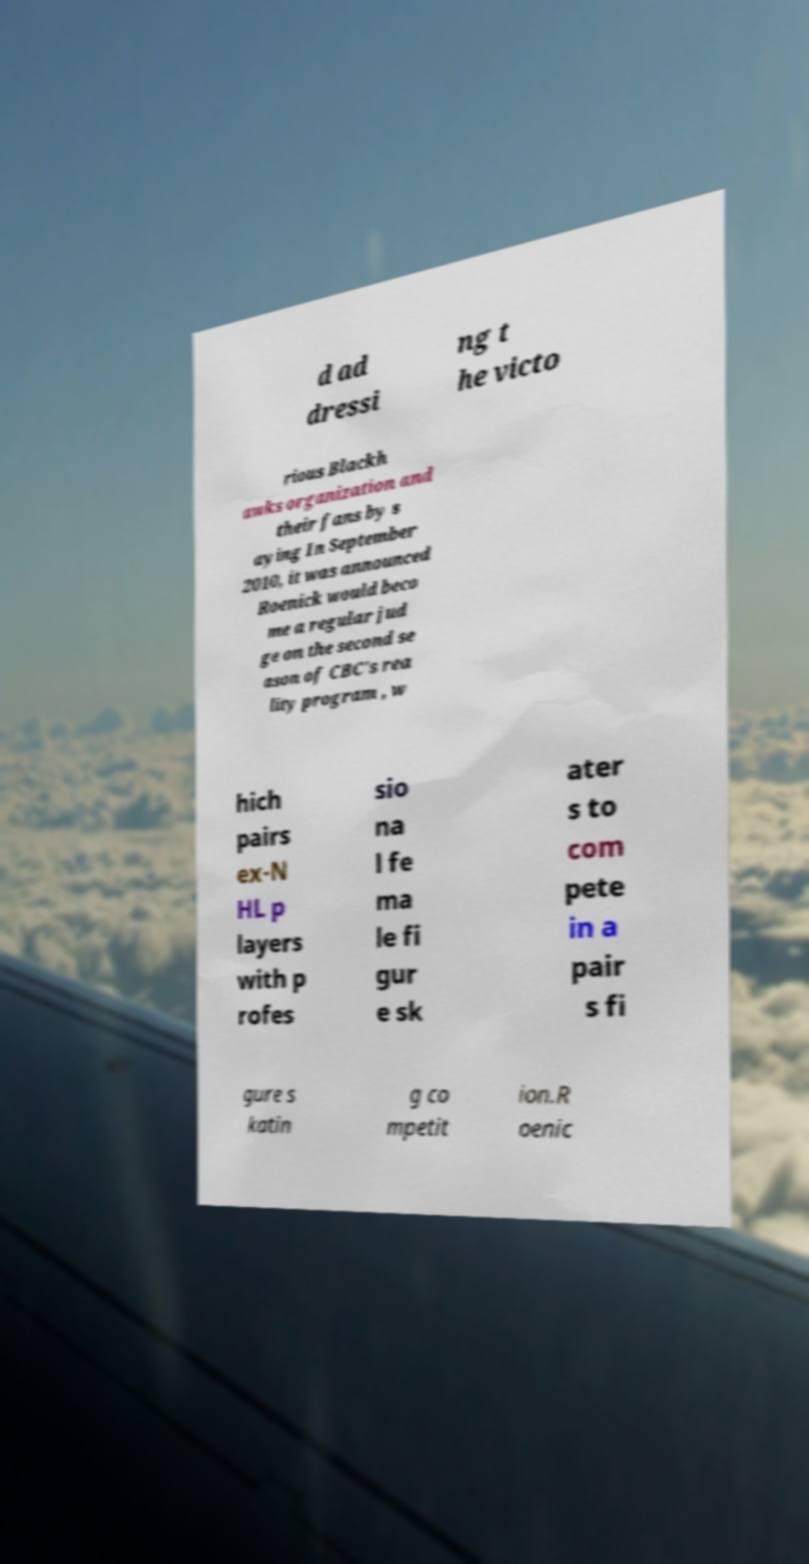Please identify and transcribe the text found in this image. d ad dressi ng t he victo rious Blackh awks organization and their fans by s aying In September 2010, it was announced Roenick would beco me a regular jud ge on the second se ason of CBC's rea lity program , w hich pairs ex-N HL p layers with p rofes sio na l fe ma le fi gur e sk ater s to com pete in a pair s fi gure s katin g co mpetit ion.R oenic 